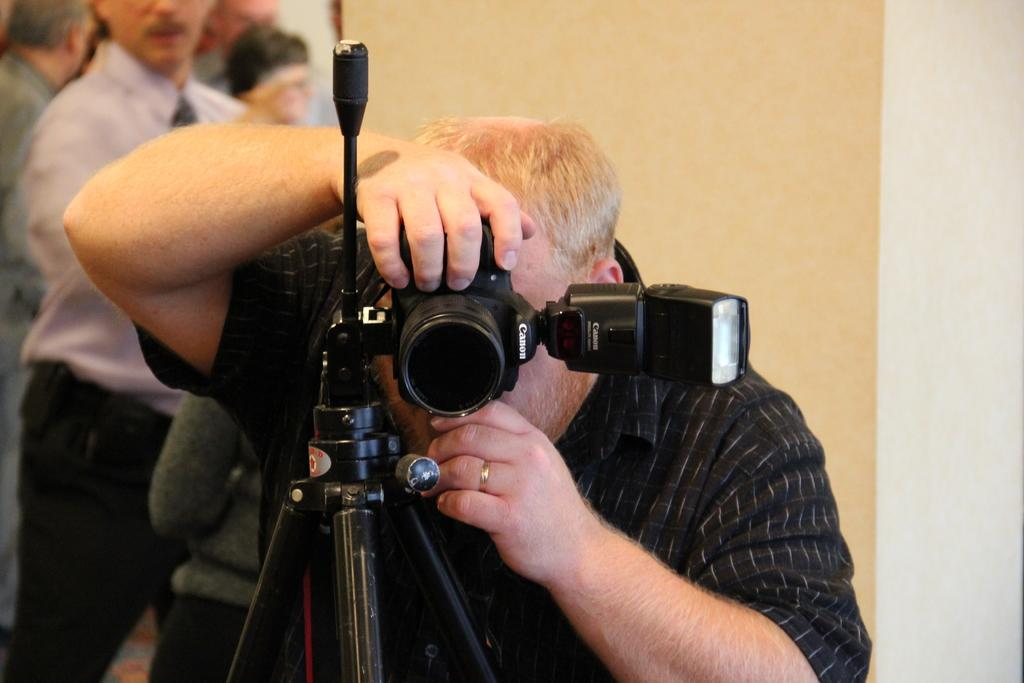What is the photographer doing in the image? The photographer is taking a picture. Who or what is the photographer capturing in the image? The information provided does not specify who or what the photographer is capturing. Are there any other people present in the image besides the photographer? Yes, there are people behind the photographer. What color is the rake being used by the photographer in the image? There is no rake present in the image; the photographer is taking a picture. 